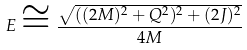Convert formula to latex. <formula><loc_0><loc_0><loc_500><loc_500>E \cong \frac { \sqrt { ( ( 2 M ) ^ { 2 } + Q ^ { 2 } ) ^ { 2 } + ( 2 J ) ^ { 2 } } } { 4 M }</formula> 